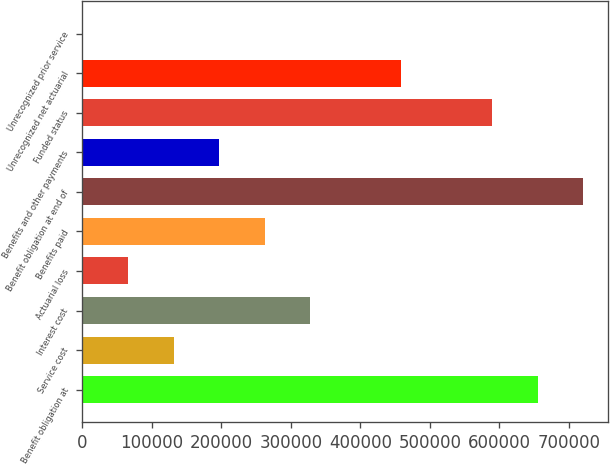Convert chart. <chart><loc_0><loc_0><loc_500><loc_500><bar_chart><fcel>Benefit obligation at<fcel>Service cost<fcel>Interest cost<fcel>Actuarial loss<fcel>Benefits paid<fcel>Benefit obligation at end of<fcel>Benefits and other payments<fcel>Funded status<fcel>Unrecognized net actuarial<fcel>Unrecognized prior service<nl><fcel>654886<fcel>131379<fcel>327694<fcel>65940.4<fcel>262256<fcel>720324<fcel>196817<fcel>589448<fcel>458571<fcel>502<nl></chart> 